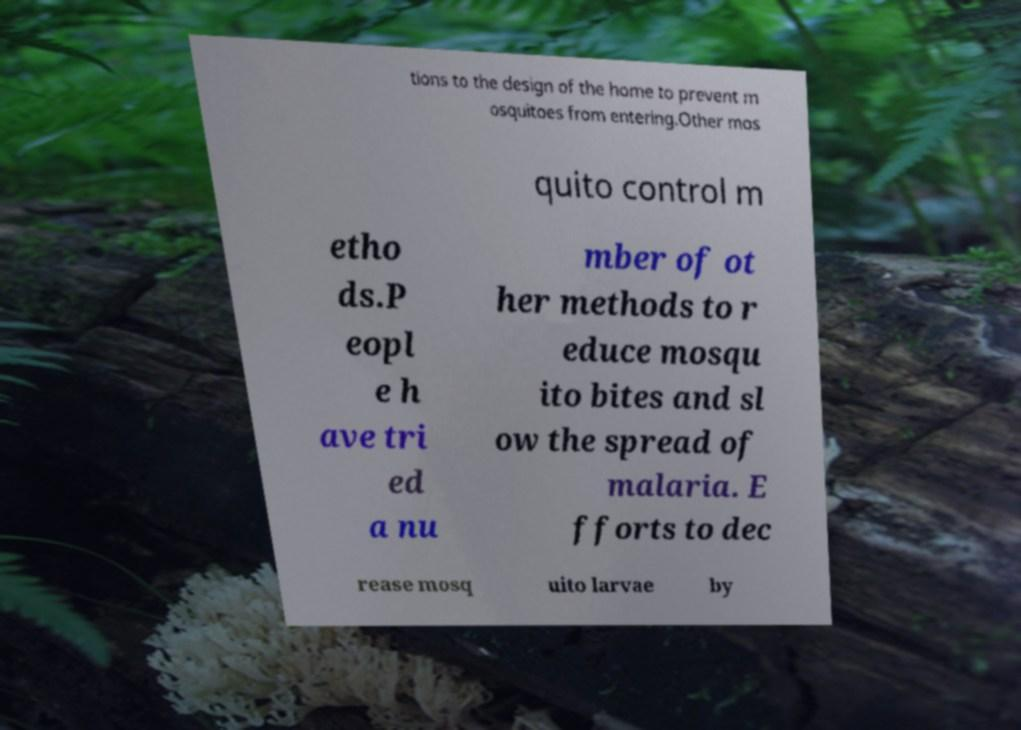I need the written content from this picture converted into text. Can you do that? tions to the design of the home to prevent m osquitoes from entering.Other mos quito control m etho ds.P eopl e h ave tri ed a nu mber of ot her methods to r educe mosqu ito bites and sl ow the spread of malaria. E fforts to dec rease mosq uito larvae by 